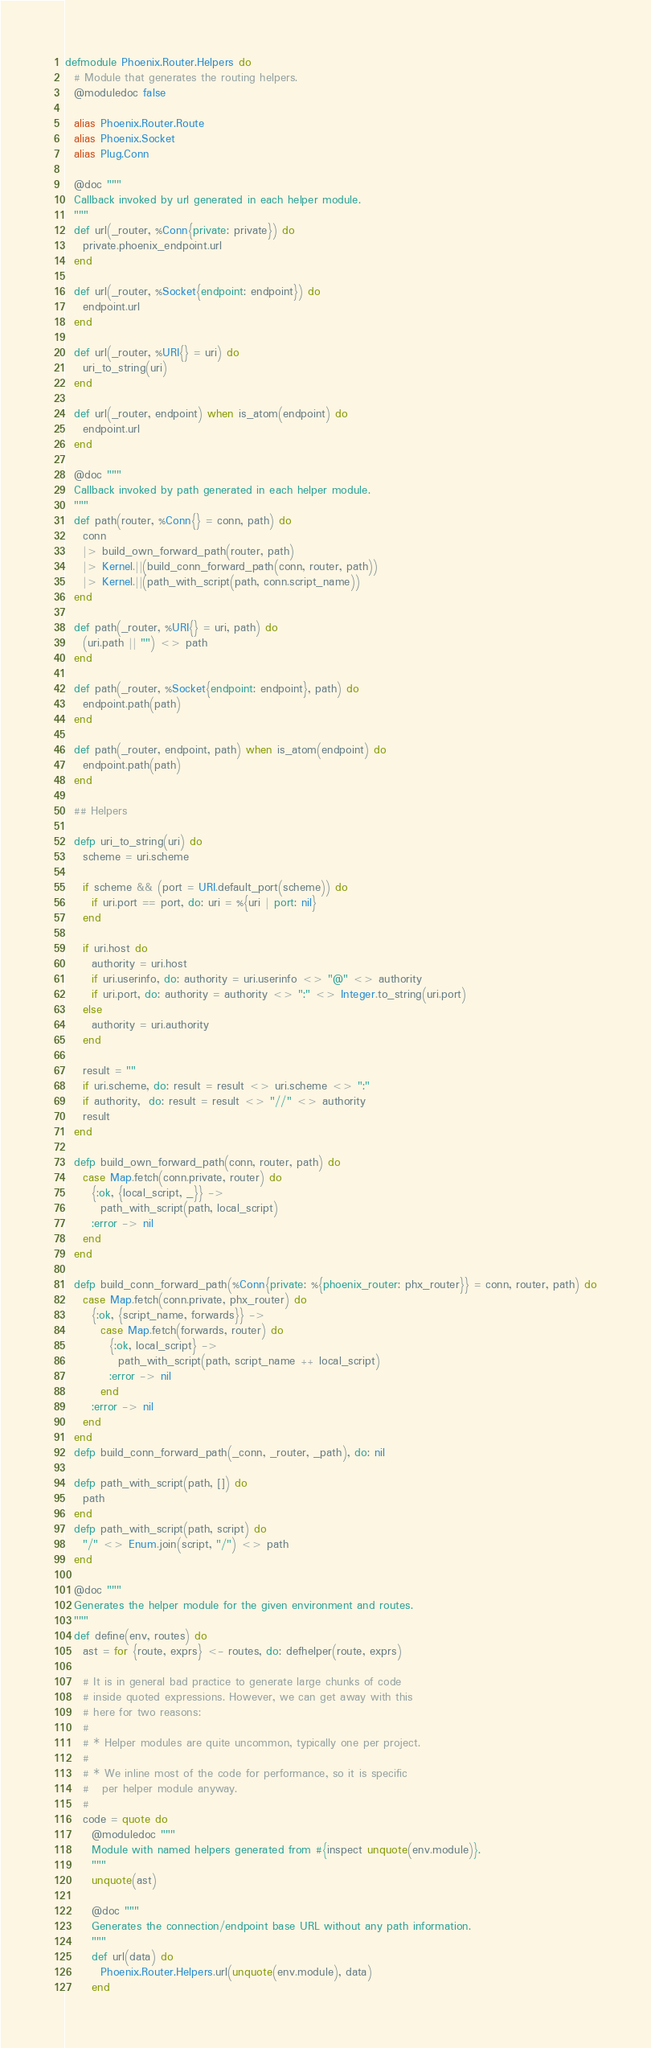<code> <loc_0><loc_0><loc_500><loc_500><_Elixir_>defmodule Phoenix.Router.Helpers do
  # Module that generates the routing helpers.
  @moduledoc false

  alias Phoenix.Router.Route
  alias Phoenix.Socket
  alias Plug.Conn

  @doc """
  Callback invoked by url generated in each helper module.
  """
  def url(_router, %Conn{private: private}) do
    private.phoenix_endpoint.url
  end

  def url(_router, %Socket{endpoint: endpoint}) do
    endpoint.url
  end

  def url(_router, %URI{} = uri) do
    uri_to_string(uri)
  end

  def url(_router, endpoint) when is_atom(endpoint) do
    endpoint.url
  end

  @doc """
  Callback invoked by path generated in each helper module.
  """
  def path(router, %Conn{} = conn, path) do
    conn
    |> build_own_forward_path(router, path)
    |> Kernel.||(build_conn_forward_path(conn, router, path))
    |> Kernel.||(path_with_script(path, conn.script_name))
  end

  def path(_router, %URI{} = uri, path) do
    (uri.path || "") <> path
  end

  def path(_router, %Socket{endpoint: endpoint}, path) do
    endpoint.path(path)
  end

  def path(_router, endpoint, path) when is_atom(endpoint) do
    endpoint.path(path)
  end

  ## Helpers

  defp uri_to_string(uri) do
    scheme = uri.scheme

    if scheme && (port = URI.default_port(scheme)) do
      if uri.port == port, do: uri = %{uri | port: nil}
    end

    if uri.host do
      authority = uri.host
      if uri.userinfo, do: authority = uri.userinfo <> "@" <> authority
      if uri.port, do: authority = authority <> ":" <> Integer.to_string(uri.port)
    else
      authority = uri.authority
    end

    result = ""
    if uri.scheme, do: result = result <> uri.scheme <> ":"
    if authority,  do: result = result <> "//" <> authority
    result
  end

  defp build_own_forward_path(conn, router, path) do
    case Map.fetch(conn.private, router) do
      {:ok, {local_script, _}} ->
        path_with_script(path, local_script)
      :error -> nil
    end
  end

  defp build_conn_forward_path(%Conn{private: %{phoenix_router: phx_router}} = conn, router, path) do
    case Map.fetch(conn.private, phx_router) do
      {:ok, {script_name, forwards}} ->
        case Map.fetch(forwards, router) do
          {:ok, local_script} ->
            path_with_script(path, script_name ++ local_script)
          :error -> nil
        end
      :error -> nil
    end
  end
  defp build_conn_forward_path(_conn, _router, _path), do: nil

  defp path_with_script(path, []) do
    path
  end
  defp path_with_script(path, script) do
    "/" <> Enum.join(script, "/") <> path
  end

  @doc """
  Generates the helper module for the given environment and routes.
  """
  def define(env, routes) do
    ast = for {route, exprs} <- routes, do: defhelper(route, exprs)

    # It is in general bad practice to generate large chunks of code
    # inside quoted expressions. However, we can get away with this
    # here for two reasons:
    #
    # * Helper modules are quite uncommon, typically one per project.
    #
    # * We inline most of the code for performance, so it is specific
    #   per helper module anyway.
    #
    code = quote do
      @moduledoc """
      Module with named helpers generated from #{inspect unquote(env.module)}.
      """
      unquote(ast)

      @doc """
      Generates the connection/endpoint base URL without any path information.
      """
      def url(data) do
        Phoenix.Router.Helpers.url(unquote(env.module), data)
      end
</code> 